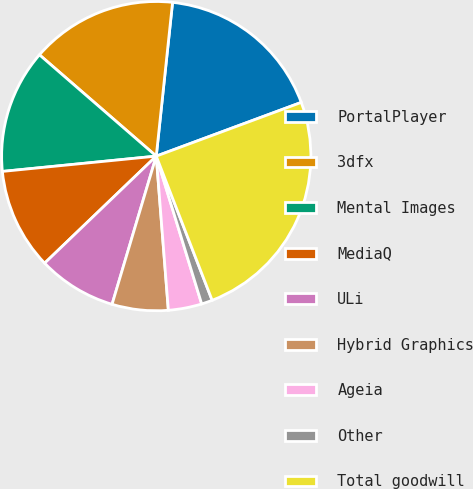Convert chart to OTSL. <chart><loc_0><loc_0><loc_500><loc_500><pie_chart><fcel>PortalPlayer<fcel>3dfx<fcel>Mental Images<fcel>MediaQ<fcel>ULi<fcel>Hybrid Graphics<fcel>Ageia<fcel>Other<fcel>Total goodwill<nl><fcel>17.67%<fcel>15.31%<fcel>12.95%<fcel>10.59%<fcel>8.22%<fcel>5.86%<fcel>3.5%<fcel>1.14%<fcel>24.76%<nl></chart> 